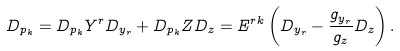<formula> <loc_0><loc_0><loc_500><loc_500>D _ { p _ { k } } = D _ { p _ { k } } Y ^ { r } D _ { y _ { r } } + D _ { p _ { k } } Z D _ { z } = E ^ { r k } \left ( D _ { y _ { r } } - \frac { g _ { y _ { r } } } { g _ { z } } D _ { z } \right ) .</formula> 